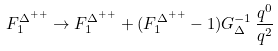Convert formula to latex. <formula><loc_0><loc_0><loc_500><loc_500>F _ { 1 } ^ { \Delta ^ { + + } } \rightarrow F _ { 1 } ^ { \Delta ^ { + + } } + ( F _ { 1 } ^ { \Delta ^ { + + } } - 1 ) G _ { \Delta } ^ { - 1 } \, \frac { q ^ { 0 } } { q ^ { 2 } }</formula> 